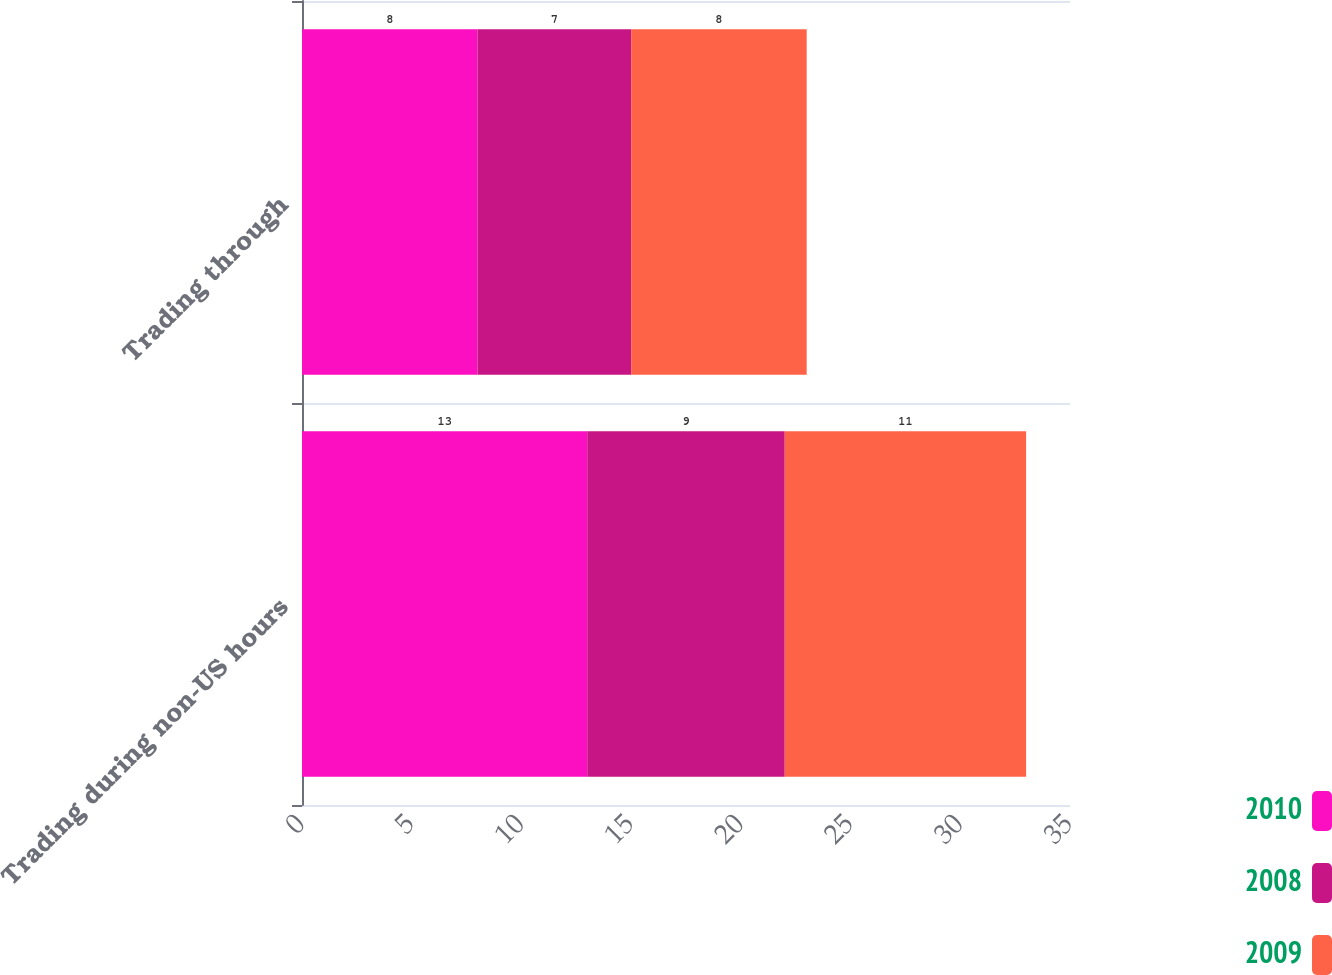Convert chart to OTSL. <chart><loc_0><loc_0><loc_500><loc_500><stacked_bar_chart><ecel><fcel>Trading during non-US hours<fcel>Trading through<nl><fcel>2010<fcel>13<fcel>8<nl><fcel>2008<fcel>9<fcel>7<nl><fcel>2009<fcel>11<fcel>8<nl></chart> 